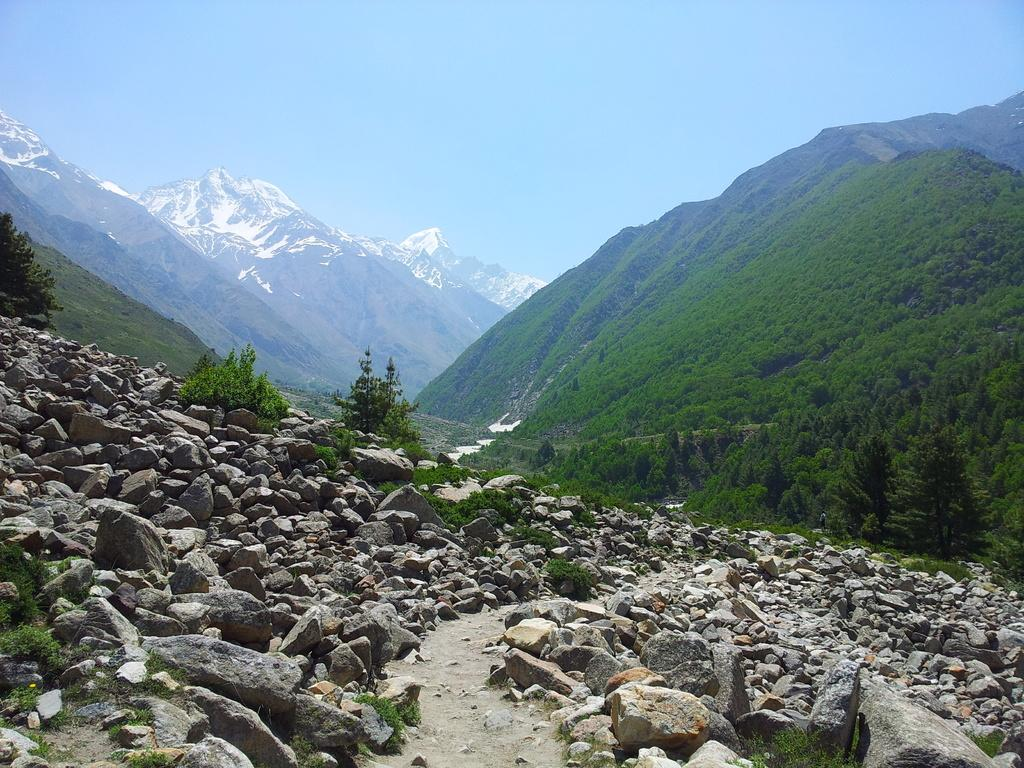What type of landscape feature is on the right side of the image? There are hills on the right side of the image. What can be seen in the background of the image? There are snow mountains in the background of the image. What is present at the bottom of the image? There are stones at the bottom of the image. What is visible at the top of the image? The sky is visible at the top of the image. Can you see the creator of the image in the picture? No, the creator of the image is not present in the picture. Is there a train visible in the image? No, there is no train present in the image. 